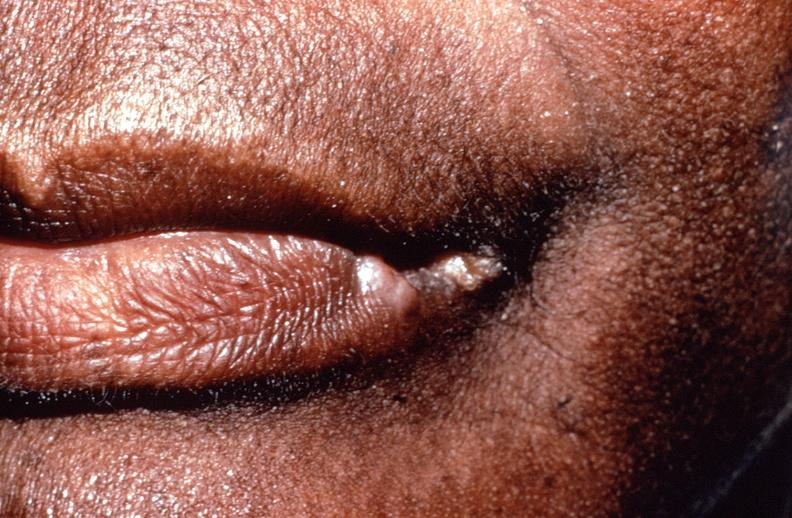where does this belong to?
Answer the question using a single word or phrase. Gastrointestinal system 